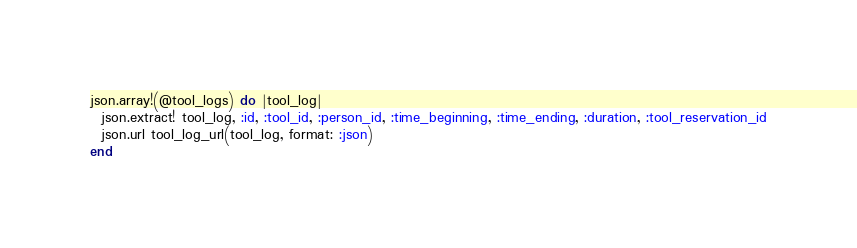Convert code to text. <code><loc_0><loc_0><loc_500><loc_500><_Ruby_>json.array!(@tool_logs) do |tool_log|
  json.extract! tool_log, :id, :tool_id, :person_id, :time_beginning, :time_ending, :duration, :tool_reservation_id
  json.url tool_log_url(tool_log, format: :json)
end
</code> 